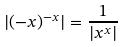Convert formula to latex. <formula><loc_0><loc_0><loc_500><loc_500>| ( - x ) ^ { - x } | = \frac { 1 } { | x ^ { x } | }</formula> 